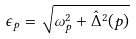<formula> <loc_0><loc_0><loc_500><loc_500>\epsilon _ { p } = \sqrt { \omega _ { p } ^ { 2 } + \hat { \Delta } ^ { 2 } ( p ) }</formula> 